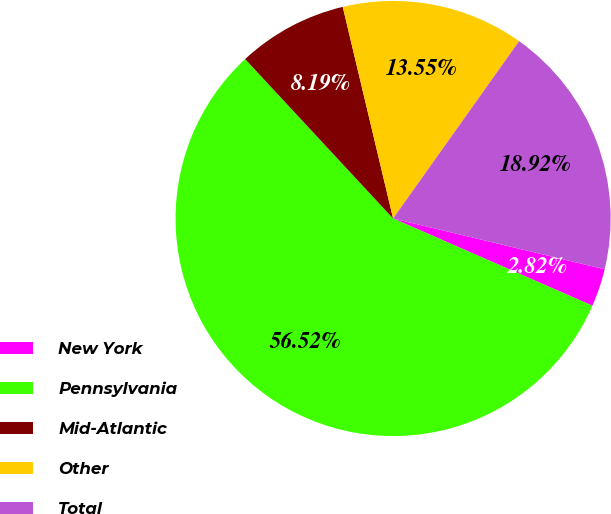Convert chart. <chart><loc_0><loc_0><loc_500><loc_500><pie_chart><fcel>New York<fcel>Pennsylvania<fcel>Mid-Atlantic<fcel>Other<fcel>Total<nl><fcel>2.82%<fcel>56.53%<fcel>8.19%<fcel>13.55%<fcel>18.92%<nl></chart> 